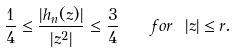<formula> <loc_0><loc_0><loc_500><loc_500>\frac { 1 } { 4 } \leq \frac { | h _ { n } ( z ) | } { | z ^ { 2 } | } \leq \frac { 3 } { 4 } \quad f o r \ | z | \leq r .</formula> 